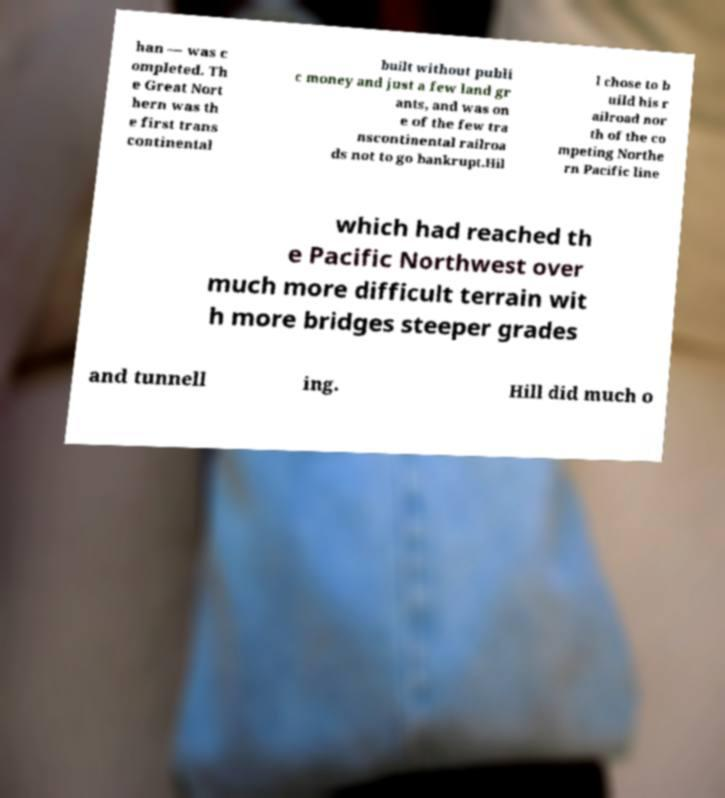Please read and relay the text visible in this image. What does it say? han — was c ompleted. Th e Great Nort hern was th e first trans continental built without publi c money and just a few land gr ants, and was on e of the few tra nscontinental railroa ds not to go bankrupt.Hil l chose to b uild his r ailroad nor th of the co mpeting Northe rn Pacific line which had reached th e Pacific Northwest over much more difficult terrain wit h more bridges steeper grades and tunnell ing. Hill did much o 